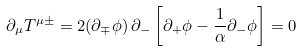Convert formula to latex. <formula><loc_0><loc_0><loc_500><loc_500>\partial _ { \mu } T ^ { \mu \pm } = 2 ( \partial _ { \mp } \phi ) \, \partial _ { - } \left [ \partial _ { + } \phi - \frac { 1 } { \alpha } \partial _ { - } \phi \right ] = 0</formula> 